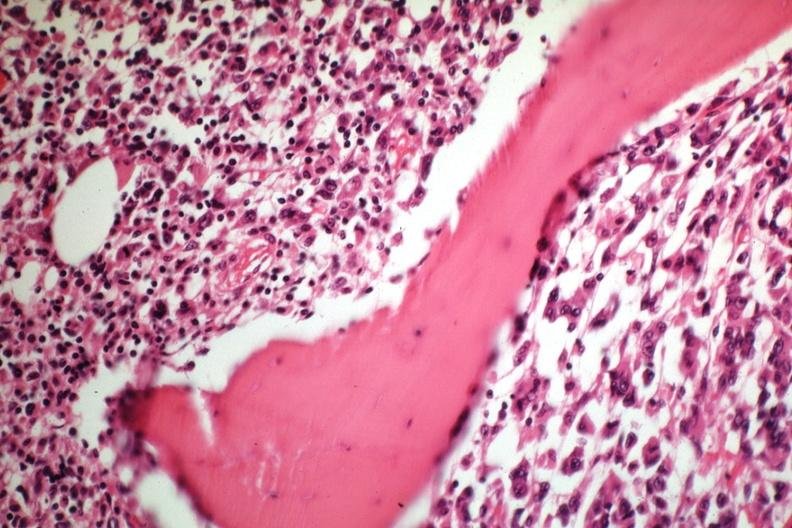what is present?
Answer the question using a single word or phrase. Joints 